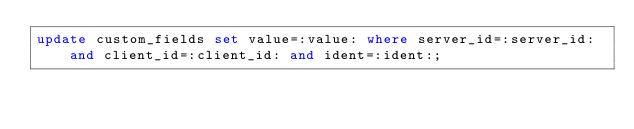Convert code to text. <code><loc_0><loc_0><loc_500><loc_500><_SQL_>update custom_fields set value=:value: where server_id=:server_id: and client_id=:client_id: and ident=:ident:;
</code> 